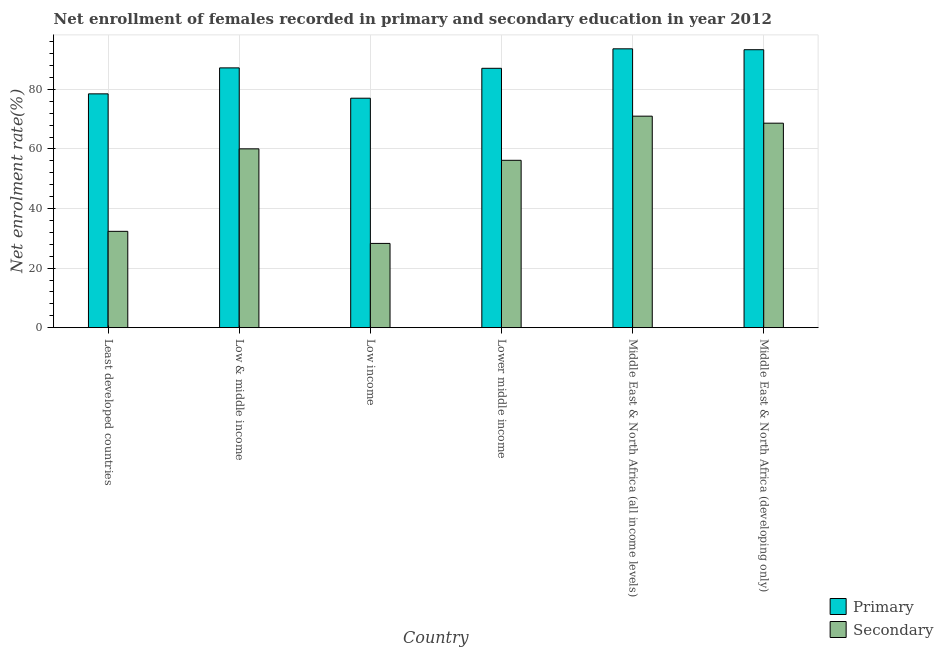How many bars are there on the 5th tick from the right?
Your response must be concise. 2. What is the label of the 3rd group of bars from the left?
Ensure brevity in your answer.  Low income. In how many cases, is the number of bars for a given country not equal to the number of legend labels?
Your answer should be very brief. 0. What is the enrollment rate in secondary education in Middle East & North Africa (all income levels)?
Ensure brevity in your answer.  71. Across all countries, what is the maximum enrollment rate in primary education?
Ensure brevity in your answer.  93.61. Across all countries, what is the minimum enrollment rate in secondary education?
Your answer should be compact. 28.28. In which country was the enrollment rate in primary education maximum?
Provide a succinct answer. Middle East & North Africa (all income levels). What is the total enrollment rate in secondary education in the graph?
Provide a succinct answer. 316.47. What is the difference between the enrollment rate in primary education in Least developed countries and that in Lower middle income?
Provide a short and direct response. -8.58. What is the difference between the enrollment rate in primary education in Middle East & North Africa (all income levels) and the enrollment rate in secondary education in Least developed countries?
Offer a very short reply. 61.27. What is the average enrollment rate in primary education per country?
Offer a terse response. 86.12. What is the difference between the enrollment rate in primary education and enrollment rate in secondary education in Middle East & North Africa (all income levels)?
Provide a short and direct response. 22.61. What is the ratio of the enrollment rate in secondary education in Lower middle income to that in Middle East & North Africa (all income levels)?
Keep it short and to the point. 0.79. Is the enrollment rate in primary education in Least developed countries less than that in Lower middle income?
Give a very brief answer. Yes. Is the difference between the enrollment rate in primary education in Low & middle income and Middle East & North Africa (all income levels) greater than the difference between the enrollment rate in secondary education in Low & middle income and Middle East & North Africa (all income levels)?
Make the answer very short. Yes. What is the difference between the highest and the second highest enrollment rate in secondary education?
Ensure brevity in your answer.  2.35. What is the difference between the highest and the lowest enrollment rate in primary education?
Give a very brief answer. 16.58. What does the 2nd bar from the left in Middle East & North Africa (developing only) represents?
Your response must be concise. Secondary. What does the 2nd bar from the right in Lower middle income represents?
Ensure brevity in your answer.  Primary. How many bars are there?
Give a very brief answer. 12. Are all the bars in the graph horizontal?
Make the answer very short. No. How many countries are there in the graph?
Make the answer very short. 6. What is the difference between two consecutive major ticks on the Y-axis?
Provide a short and direct response. 20. Are the values on the major ticks of Y-axis written in scientific E-notation?
Offer a terse response. No. Does the graph contain any zero values?
Offer a very short reply. No. Where does the legend appear in the graph?
Keep it short and to the point. Bottom right. What is the title of the graph?
Keep it short and to the point. Net enrollment of females recorded in primary and secondary education in year 2012. What is the label or title of the Y-axis?
Provide a short and direct response. Net enrolment rate(%). What is the Net enrolment rate(%) in Primary in Least developed countries?
Give a very brief answer. 78.49. What is the Net enrolment rate(%) of Secondary in Least developed countries?
Your response must be concise. 32.34. What is the Net enrolment rate(%) in Primary in Low & middle income?
Keep it short and to the point. 87.21. What is the Net enrolment rate(%) in Secondary in Low & middle income?
Offer a terse response. 60.02. What is the Net enrolment rate(%) in Primary in Low income?
Your answer should be compact. 77.03. What is the Net enrolment rate(%) of Secondary in Low income?
Your response must be concise. 28.28. What is the Net enrolment rate(%) of Primary in Lower middle income?
Your response must be concise. 87.07. What is the Net enrolment rate(%) in Secondary in Lower middle income?
Offer a terse response. 56.18. What is the Net enrolment rate(%) of Primary in Middle East & North Africa (all income levels)?
Ensure brevity in your answer.  93.61. What is the Net enrolment rate(%) in Secondary in Middle East & North Africa (all income levels)?
Your answer should be very brief. 71. What is the Net enrolment rate(%) of Primary in Middle East & North Africa (developing only)?
Your answer should be very brief. 93.3. What is the Net enrolment rate(%) of Secondary in Middle East & North Africa (developing only)?
Offer a very short reply. 68.65. Across all countries, what is the maximum Net enrolment rate(%) of Primary?
Keep it short and to the point. 93.61. Across all countries, what is the maximum Net enrolment rate(%) of Secondary?
Offer a very short reply. 71. Across all countries, what is the minimum Net enrolment rate(%) in Primary?
Offer a very short reply. 77.03. Across all countries, what is the minimum Net enrolment rate(%) of Secondary?
Keep it short and to the point. 28.28. What is the total Net enrolment rate(%) in Primary in the graph?
Provide a short and direct response. 516.69. What is the total Net enrolment rate(%) of Secondary in the graph?
Your answer should be compact. 316.47. What is the difference between the Net enrolment rate(%) of Primary in Least developed countries and that in Low & middle income?
Your response must be concise. -8.72. What is the difference between the Net enrolment rate(%) in Secondary in Least developed countries and that in Low & middle income?
Your answer should be compact. -27.69. What is the difference between the Net enrolment rate(%) in Primary in Least developed countries and that in Low income?
Keep it short and to the point. 1.46. What is the difference between the Net enrolment rate(%) of Secondary in Least developed countries and that in Low income?
Your response must be concise. 4.05. What is the difference between the Net enrolment rate(%) of Primary in Least developed countries and that in Lower middle income?
Offer a terse response. -8.58. What is the difference between the Net enrolment rate(%) in Secondary in Least developed countries and that in Lower middle income?
Make the answer very short. -23.84. What is the difference between the Net enrolment rate(%) of Primary in Least developed countries and that in Middle East & North Africa (all income levels)?
Your response must be concise. -15.12. What is the difference between the Net enrolment rate(%) of Secondary in Least developed countries and that in Middle East & North Africa (all income levels)?
Your answer should be compact. -38.66. What is the difference between the Net enrolment rate(%) of Primary in Least developed countries and that in Middle East & North Africa (developing only)?
Make the answer very short. -14.82. What is the difference between the Net enrolment rate(%) of Secondary in Least developed countries and that in Middle East & North Africa (developing only)?
Your answer should be compact. -36.31. What is the difference between the Net enrolment rate(%) in Primary in Low & middle income and that in Low income?
Your answer should be compact. 10.18. What is the difference between the Net enrolment rate(%) of Secondary in Low & middle income and that in Low income?
Your answer should be compact. 31.74. What is the difference between the Net enrolment rate(%) in Primary in Low & middle income and that in Lower middle income?
Keep it short and to the point. 0.14. What is the difference between the Net enrolment rate(%) in Secondary in Low & middle income and that in Lower middle income?
Your answer should be very brief. 3.84. What is the difference between the Net enrolment rate(%) of Primary in Low & middle income and that in Middle East & North Africa (all income levels)?
Your response must be concise. -6.4. What is the difference between the Net enrolment rate(%) in Secondary in Low & middle income and that in Middle East & North Africa (all income levels)?
Keep it short and to the point. -10.98. What is the difference between the Net enrolment rate(%) of Primary in Low & middle income and that in Middle East & North Africa (developing only)?
Your answer should be compact. -6.1. What is the difference between the Net enrolment rate(%) of Secondary in Low & middle income and that in Middle East & North Africa (developing only)?
Make the answer very short. -8.62. What is the difference between the Net enrolment rate(%) of Primary in Low income and that in Lower middle income?
Provide a short and direct response. -10.04. What is the difference between the Net enrolment rate(%) of Secondary in Low income and that in Lower middle income?
Your answer should be compact. -27.9. What is the difference between the Net enrolment rate(%) of Primary in Low income and that in Middle East & North Africa (all income levels)?
Offer a very short reply. -16.58. What is the difference between the Net enrolment rate(%) of Secondary in Low income and that in Middle East & North Africa (all income levels)?
Offer a very short reply. -42.72. What is the difference between the Net enrolment rate(%) of Primary in Low income and that in Middle East & North Africa (developing only)?
Offer a terse response. -16.28. What is the difference between the Net enrolment rate(%) of Secondary in Low income and that in Middle East & North Africa (developing only)?
Provide a succinct answer. -40.36. What is the difference between the Net enrolment rate(%) in Primary in Lower middle income and that in Middle East & North Africa (all income levels)?
Offer a terse response. -6.54. What is the difference between the Net enrolment rate(%) of Secondary in Lower middle income and that in Middle East & North Africa (all income levels)?
Ensure brevity in your answer.  -14.82. What is the difference between the Net enrolment rate(%) of Primary in Lower middle income and that in Middle East & North Africa (developing only)?
Offer a very short reply. -6.24. What is the difference between the Net enrolment rate(%) of Secondary in Lower middle income and that in Middle East & North Africa (developing only)?
Keep it short and to the point. -12.47. What is the difference between the Net enrolment rate(%) of Primary in Middle East & North Africa (all income levels) and that in Middle East & North Africa (developing only)?
Provide a short and direct response. 0.3. What is the difference between the Net enrolment rate(%) of Secondary in Middle East & North Africa (all income levels) and that in Middle East & North Africa (developing only)?
Provide a succinct answer. 2.35. What is the difference between the Net enrolment rate(%) of Primary in Least developed countries and the Net enrolment rate(%) of Secondary in Low & middle income?
Provide a short and direct response. 18.46. What is the difference between the Net enrolment rate(%) in Primary in Least developed countries and the Net enrolment rate(%) in Secondary in Low income?
Keep it short and to the point. 50.2. What is the difference between the Net enrolment rate(%) of Primary in Least developed countries and the Net enrolment rate(%) of Secondary in Lower middle income?
Offer a very short reply. 22.31. What is the difference between the Net enrolment rate(%) in Primary in Least developed countries and the Net enrolment rate(%) in Secondary in Middle East & North Africa (all income levels)?
Provide a short and direct response. 7.49. What is the difference between the Net enrolment rate(%) in Primary in Least developed countries and the Net enrolment rate(%) in Secondary in Middle East & North Africa (developing only)?
Your answer should be compact. 9.84. What is the difference between the Net enrolment rate(%) of Primary in Low & middle income and the Net enrolment rate(%) of Secondary in Low income?
Provide a succinct answer. 58.92. What is the difference between the Net enrolment rate(%) in Primary in Low & middle income and the Net enrolment rate(%) in Secondary in Lower middle income?
Offer a terse response. 31.03. What is the difference between the Net enrolment rate(%) of Primary in Low & middle income and the Net enrolment rate(%) of Secondary in Middle East & North Africa (all income levels)?
Your answer should be very brief. 16.21. What is the difference between the Net enrolment rate(%) of Primary in Low & middle income and the Net enrolment rate(%) of Secondary in Middle East & North Africa (developing only)?
Provide a succinct answer. 18.56. What is the difference between the Net enrolment rate(%) of Primary in Low income and the Net enrolment rate(%) of Secondary in Lower middle income?
Make the answer very short. 20.85. What is the difference between the Net enrolment rate(%) in Primary in Low income and the Net enrolment rate(%) in Secondary in Middle East & North Africa (all income levels)?
Ensure brevity in your answer.  6.03. What is the difference between the Net enrolment rate(%) in Primary in Low income and the Net enrolment rate(%) in Secondary in Middle East & North Africa (developing only)?
Provide a short and direct response. 8.38. What is the difference between the Net enrolment rate(%) in Primary in Lower middle income and the Net enrolment rate(%) in Secondary in Middle East & North Africa (all income levels)?
Make the answer very short. 16.07. What is the difference between the Net enrolment rate(%) of Primary in Lower middle income and the Net enrolment rate(%) of Secondary in Middle East & North Africa (developing only)?
Give a very brief answer. 18.42. What is the difference between the Net enrolment rate(%) of Primary in Middle East & North Africa (all income levels) and the Net enrolment rate(%) of Secondary in Middle East & North Africa (developing only)?
Your response must be concise. 24.96. What is the average Net enrolment rate(%) of Primary per country?
Ensure brevity in your answer.  86.12. What is the average Net enrolment rate(%) in Secondary per country?
Your answer should be very brief. 52.74. What is the difference between the Net enrolment rate(%) of Primary and Net enrolment rate(%) of Secondary in Least developed countries?
Your response must be concise. 46.15. What is the difference between the Net enrolment rate(%) in Primary and Net enrolment rate(%) in Secondary in Low & middle income?
Make the answer very short. 27.18. What is the difference between the Net enrolment rate(%) in Primary and Net enrolment rate(%) in Secondary in Low income?
Your answer should be compact. 48.74. What is the difference between the Net enrolment rate(%) in Primary and Net enrolment rate(%) in Secondary in Lower middle income?
Offer a very short reply. 30.89. What is the difference between the Net enrolment rate(%) in Primary and Net enrolment rate(%) in Secondary in Middle East & North Africa (all income levels)?
Offer a terse response. 22.61. What is the difference between the Net enrolment rate(%) of Primary and Net enrolment rate(%) of Secondary in Middle East & North Africa (developing only)?
Offer a terse response. 24.66. What is the ratio of the Net enrolment rate(%) in Primary in Least developed countries to that in Low & middle income?
Provide a succinct answer. 0.9. What is the ratio of the Net enrolment rate(%) of Secondary in Least developed countries to that in Low & middle income?
Your answer should be compact. 0.54. What is the ratio of the Net enrolment rate(%) of Primary in Least developed countries to that in Low income?
Ensure brevity in your answer.  1.02. What is the ratio of the Net enrolment rate(%) in Secondary in Least developed countries to that in Low income?
Offer a very short reply. 1.14. What is the ratio of the Net enrolment rate(%) of Primary in Least developed countries to that in Lower middle income?
Your answer should be very brief. 0.9. What is the ratio of the Net enrolment rate(%) in Secondary in Least developed countries to that in Lower middle income?
Make the answer very short. 0.58. What is the ratio of the Net enrolment rate(%) in Primary in Least developed countries to that in Middle East & North Africa (all income levels)?
Provide a succinct answer. 0.84. What is the ratio of the Net enrolment rate(%) of Secondary in Least developed countries to that in Middle East & North Africa (all income levels)?
Offer a terse response. 0.46. What is the ratio of the Net enrolment rate(%) of Primary in Least developed countries to that in Middle East & North Africa (developing only)?
Your answer should be very brief. 0.84. What is the ratio of the Net enrolment rate(%) of Secondary in Least developed countries to that in Middle East & North Africa (developing only)?
Your response must be concise. 0.47. What is the ratio of the Net enrolment rate(%) in Primary in Low & middle income to that in Low income?
Your answer should be very brief. 1.13. What is the ratio of the Net enrolment rate(%) of Secondary in Low & middle income to that in Low income?
Your answer should be very brief. 2.12. What is the ratio of the Net enrolment rate(%) of Secondary in Low & middle income to that in Lower middle income?
Make the answer very short. 1.07. What is the ratio of the Net enrolment rate(%) of Primary in Low & middle income to that in Middle East & North Africa (all income levels)?
Offer a very short reply. 0.93. What is the ratio of the Net enrolment rate(%) of Secondary in Low & middle income to that in Middle East & North Africa (all income levels)?
Offer a terse response. 0.85. What is the ratio of the Net enrolment rate(%) in Primary in Low & middle income to that in Middle East & North Africa (developing only)?
Keep it short and to the point. 0.93. What is the ratio of the Net enrolment rate(%) of Secondary in Low & middle income to that in Middle East & North Africa (developing only)?
Your response must be concise. 0.87. What is the ratio of the Net enrolment rate(%) of Primary in Low income to that in Lower middle income?
Offer a very short reply. 0.88. What is the ratio of the Net enrolment rate(%) of Secondary in Low income to that in Lower middle income?
Provide a succinct answer. 0.5. What is the ratio of the Net enrolment rate(%) of Primary in Low income to that in Middle East & North Africa (all income levels)?
Give a very brief answer. 0.82. What is the ratio of the Net enrolment rate(%) in Secondary in Low income to that in Middle East & North Africa (all income levels)?
Provide a short and direct response. 0.4. What is the ratio of the Net enrolment rate(%) of Primary in Low income to that in Middle East & North Africa (developing only)?
Offer a terse response. 0.83. What is the ratio of the Net enrolment rate(%) of Secondary in Low income to that in Middle East & North Africa (developing only)?
Offer a terse response. 0.41. What is the ratio of the Net enrolment rate(%) of Primary in Lower middle income to that in Middle East & North Africa (all income levels)?
Make the answer very short. 0.93. What is the ratio of the Net enrolment rate(%) of Secondary in Lower middle income to that in Middle East & North Africa (all income levels)?
Ensure brevity in your answer.  0.79. What is the ratio of the Net enrolment rate(%) in Primary in Lower middle income to that in Middle East & North Africa (developing only)?
Your response must be concise. 0.93. What is the ratio of the Net enrolment rate(%) of Secondary in Lower middle income to that in Middle East & North Africa (developing only)?
Provide a succinct answer. 0.82. What is the ratio of the Net enrolment rate(%) in Secondary in Middle East & North Africa (all income levels) to that in Middle East & North Africa (developing only)?
Your answer should be compact. 1.03. What is the difference between the highest and the second highest Net enrolment rate(%) in Primary?
Provide a succinct answer. 0.3. What is the difference between the highest and the second highest Net enrolment rate(%) in Secondary?
Your response must be concise. 2.35. What is the difference between the highest and the lowest Net enrolment rate(%) of Primary?
Your response must be concise. 16.58. What is the difference between the highest and the lowest Net enrolment rate(%) of Secondary?
Provide a succinct answer. 42.72. 